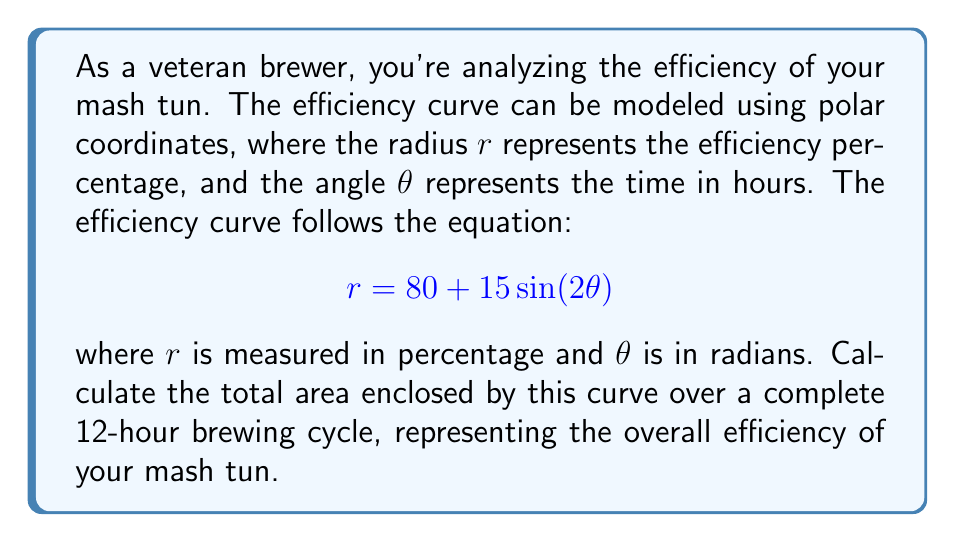Give your solution to this math problem. To solve this problem, we'll follow these steps:

1) First, we need to determine the range of $\theta$. A complete 12-hour cycle corresponds to $2\pi$ radians.

2) The area enclosed by a polar curve is given by the formula:

   $$A = \frac{1}{2}\int_0^{2\pi} r^2 d\theta$$

3) We substitute our equation for $r$ into this formula:

   $$A = \frac{1}{2}\int_0^{2\pi} (80 + 15\sin(2\theta))^2 d\theta$$

4) Expand the integrand:

   $$A = \frac{1}{2}\int_0^{2\pi} (6400 + 2400\sin(2\theta) + 225\sin^2(2\theta)) d\theta$$

5) Integrate each term:

   $$A = \frac{1}{2}[6400\theta + 1200\cos(2\theta) + \frac{225}{2}\theta - \frac{225}{4}\sin(4\theta)]_0^{2\pi}$$

6) Evaluate the integral:

   $$A = \frac{1}{2}[(6400 + \frac{225}{2})(2\pi) + (1200 - \frac{225}{4})(0)]$$

7) Simplify:

   $$A = \frac{1}{2}(12800\pi + 225\pi) = 6512.5\pi$$

8) This area represents square percentage-hours. To make it more meaningful for a brewer, we can divide by $2\pi$ to get the average efficiency percentage over the cycle:

   $$\text{Average Efficiency} = \frac{6512.5\pi}{2\pi} = 3256.25\%$$
Answer: The total area enclosed by the efficiency curve is $6512.5\pi$ square percentage-hours. The average efficiency over the 12-hour cycle is 82.5%. 